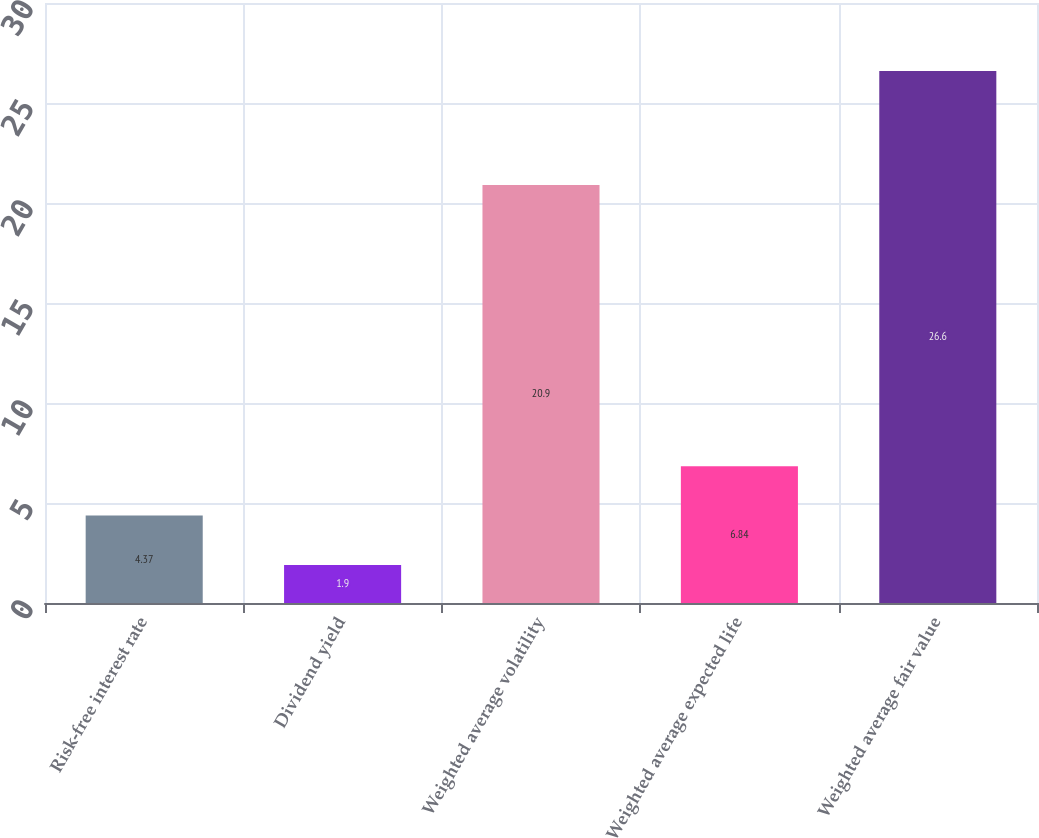Convert chart to OTSL. <chart><loc_0><loc_0><loc_500><loc_500><bar_chart><fcel>Risk-free interest rate<fcel>Dividend yield<fcel>Weighted average volatility<fcel>Weighted average expected life<fcel>Weighted average fair value<nl><fcel>4.37<fcel>1.9<fcel>20.9<fcel>6.84<fcel>26.6<nl></chart> 